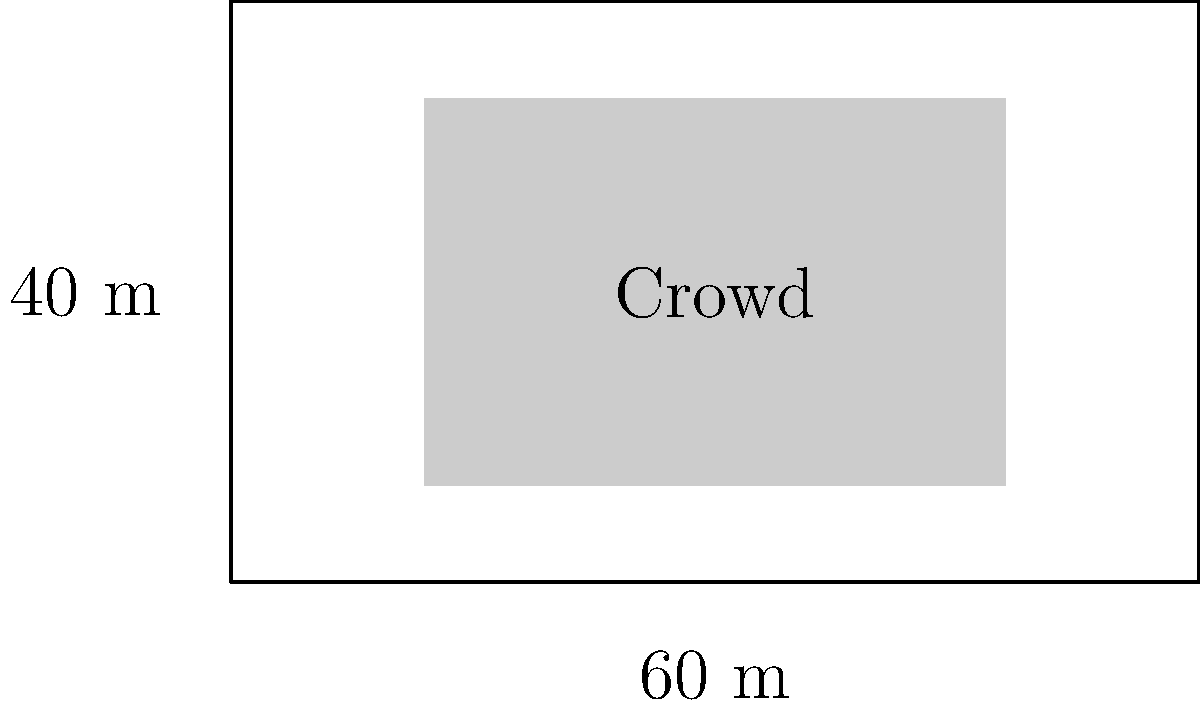At an outdoor concert in Austin, the audience area is a rectangular plot measuring 60 meters by 40 meters. If it's estimated that each person occupies about 0.5 square meters of space, and the crowd fills approximately 75% of the total area, how many people are attending the concert? Let's break this down step-by-step:

1. Calculate the total area of the rectangular plot:
   $$ \text{Area} = \text{Length} \times \text{Width} $$
   $$ \text{Area} = 60 \text{ m} \times 40 \text{ m} = 2400 \text{ m}^2 $$

2. Calculate 75% of the total area (the area occupied by the crowd):
   $$ \text{Crowd Area} = 75\% \text{ of } 2400 \text{ m}^2 = 0.75 \times 2400 \text{ m}^2 = 1800 \text{ m}^2 $$

3. Calculate the number of people in the crowd:
   Given that each person occupies 0.5 square meters:
   $$ \text{Number of people} = \frac{\text{Crowd Area}}{\text{Area per person}} $$
   $$ \text{Number of people} = \frac{1800 \text{ m}^2}{0.5 \text{ m}^2/\text{person}} = 3600 \text{ people} $$

Therefore, the estimated number of people attending the concert is 3600.
Answer: 3600 people 